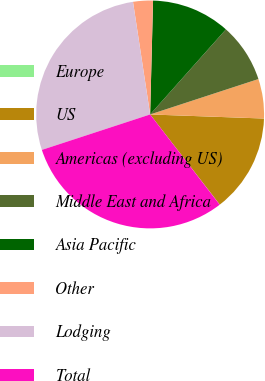Convert chart. <chart><loc_0><loc_0><loc_500><loc_500><pie_chart><fcel>Europe<fcel>US<fcel>Americas (excluding US)<fcel>Middle East and Africa<fcel>Asia Pacific<fcel>Other<fcel>Lodging<fcel>Total<nl><fcel>0.02%<fcel>13.96%<fcel>5.6%<fcel>8.39%<fcel>11.17%<fcel>2.81%<fcel>27.63%<fcel>30.41%<nl></chart> 